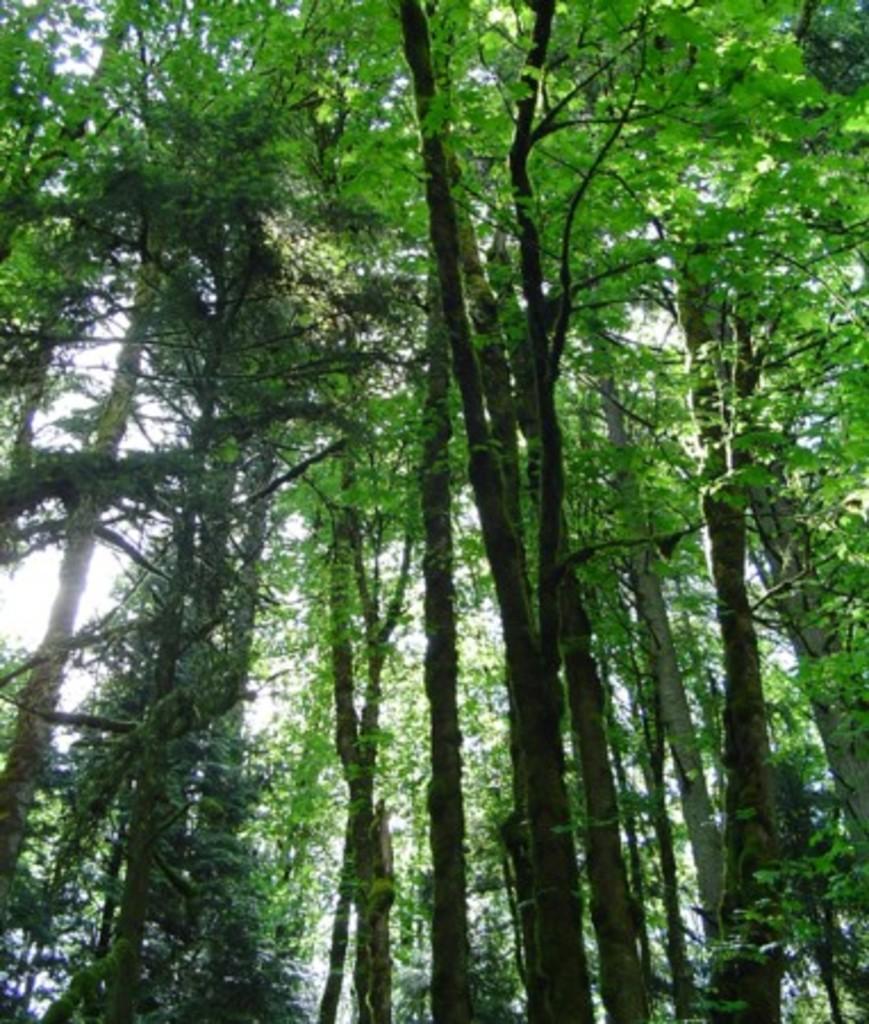Describe this image in one or two sentences. In the image in the center we can see the sky,clouds and trees. 